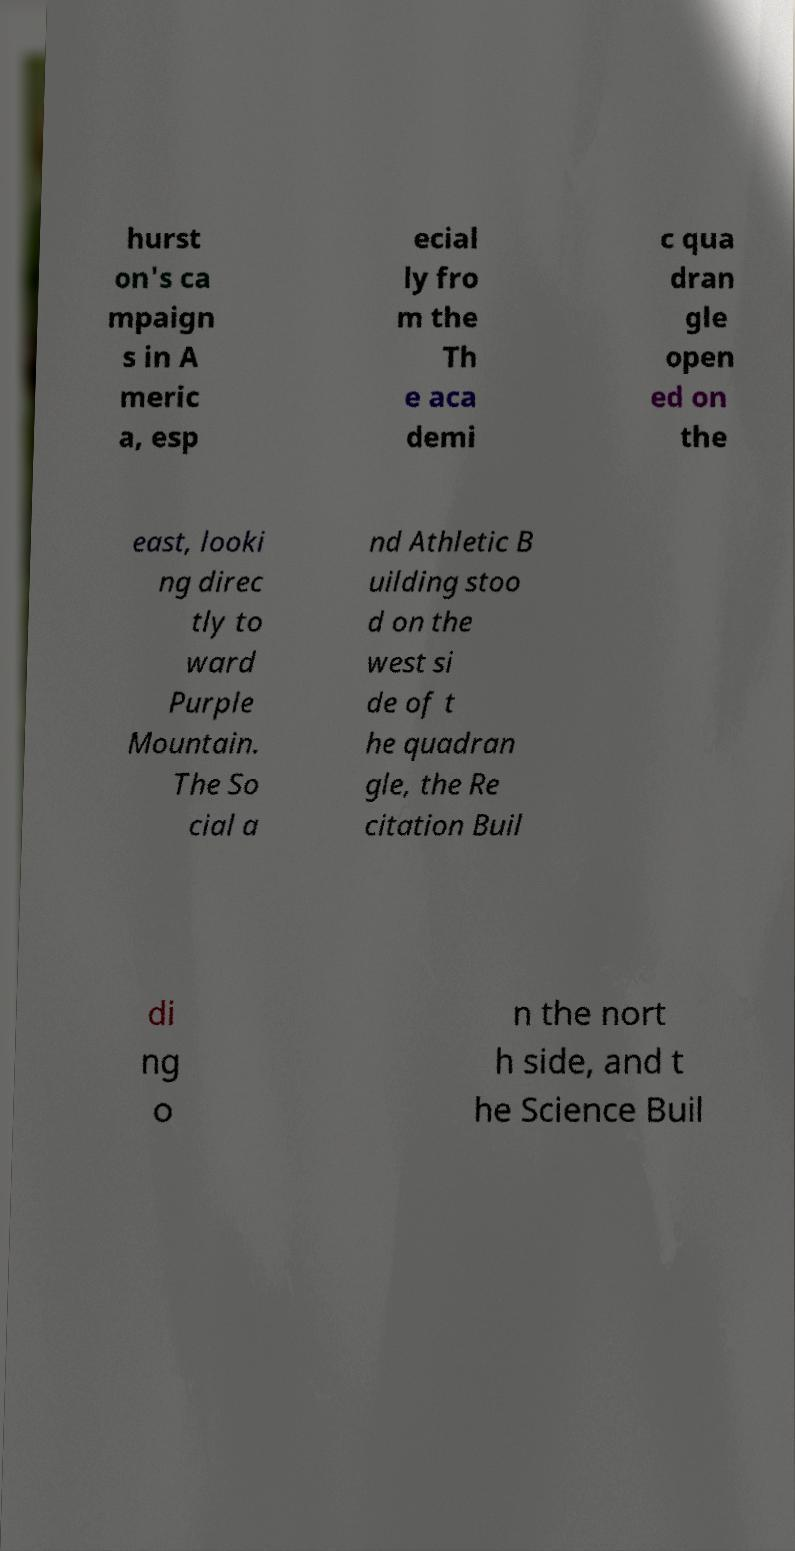There's text embedded in this image that I need extracted. Can you transcribe it verbatim? hurst on's ca mpaign s in A meric a, esp ecial ly fro m the Th e aca demi c qua dran gle open ed on the east, looki ng direc tly to ward Purple Mountain. The So cial a nd Athletic B uilding stoo d on the west si de of t he quadran gle, the Re citation Buil di ng o n the nort h side, and t he Science Buil 